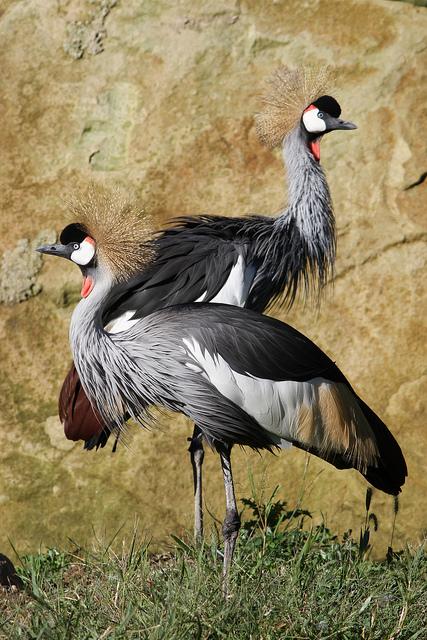What type of bird are these?
Quick response, please. Killdeer. What material is the bird standing on?
Keep it brief. Grass. Are these peacocks?
Keep it brief. Yes. Does one of these animals seem to have more alpha energy than the other one?
Write a very short answer. No. How are they facing in relation to each other?
Write a very short answer. Opposite. Are the birds wild?
Be succinct. Yes. Are these birds in the wild?
Answer briefly. Yes. Are these birds are very common in the wild in northern Michigan?
Answer briefly. No. What color is the bird's beak?
Keep it brief. Gray. 